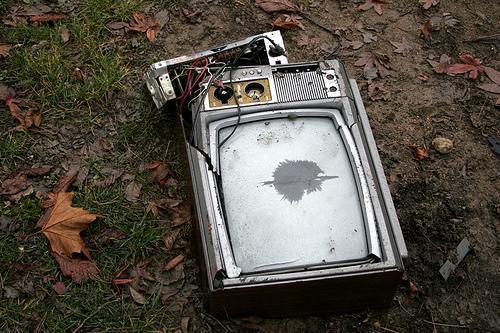How many televisions are in the image?
Give a very brief answer. 1. 